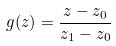Convert formula to latex. <formula><loc_0><loc_0><loc_500><loc_500>g ( z ) = \frac { z - z _ { 0 } } { z _ { 1 } - z _ { 0 } }</formula> 